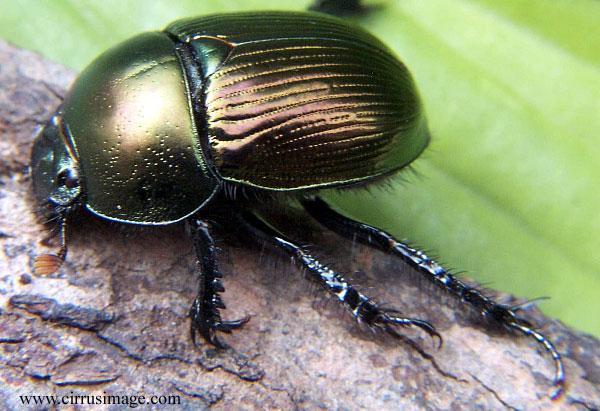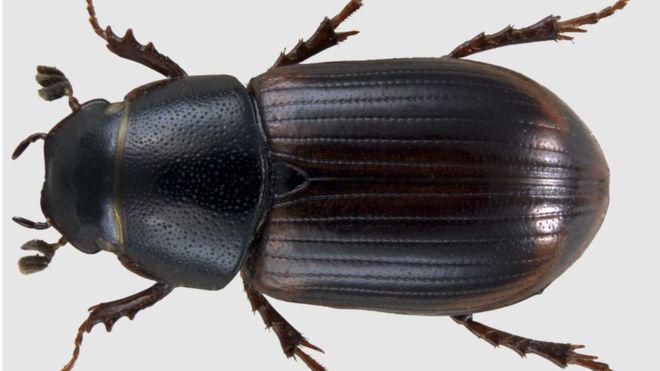The first image is the image on the left, the second image is the image on the right. Considering the images on both sides, is "There is a single black beetle in the image on the right." valid? Answer yes or no. Yes. 